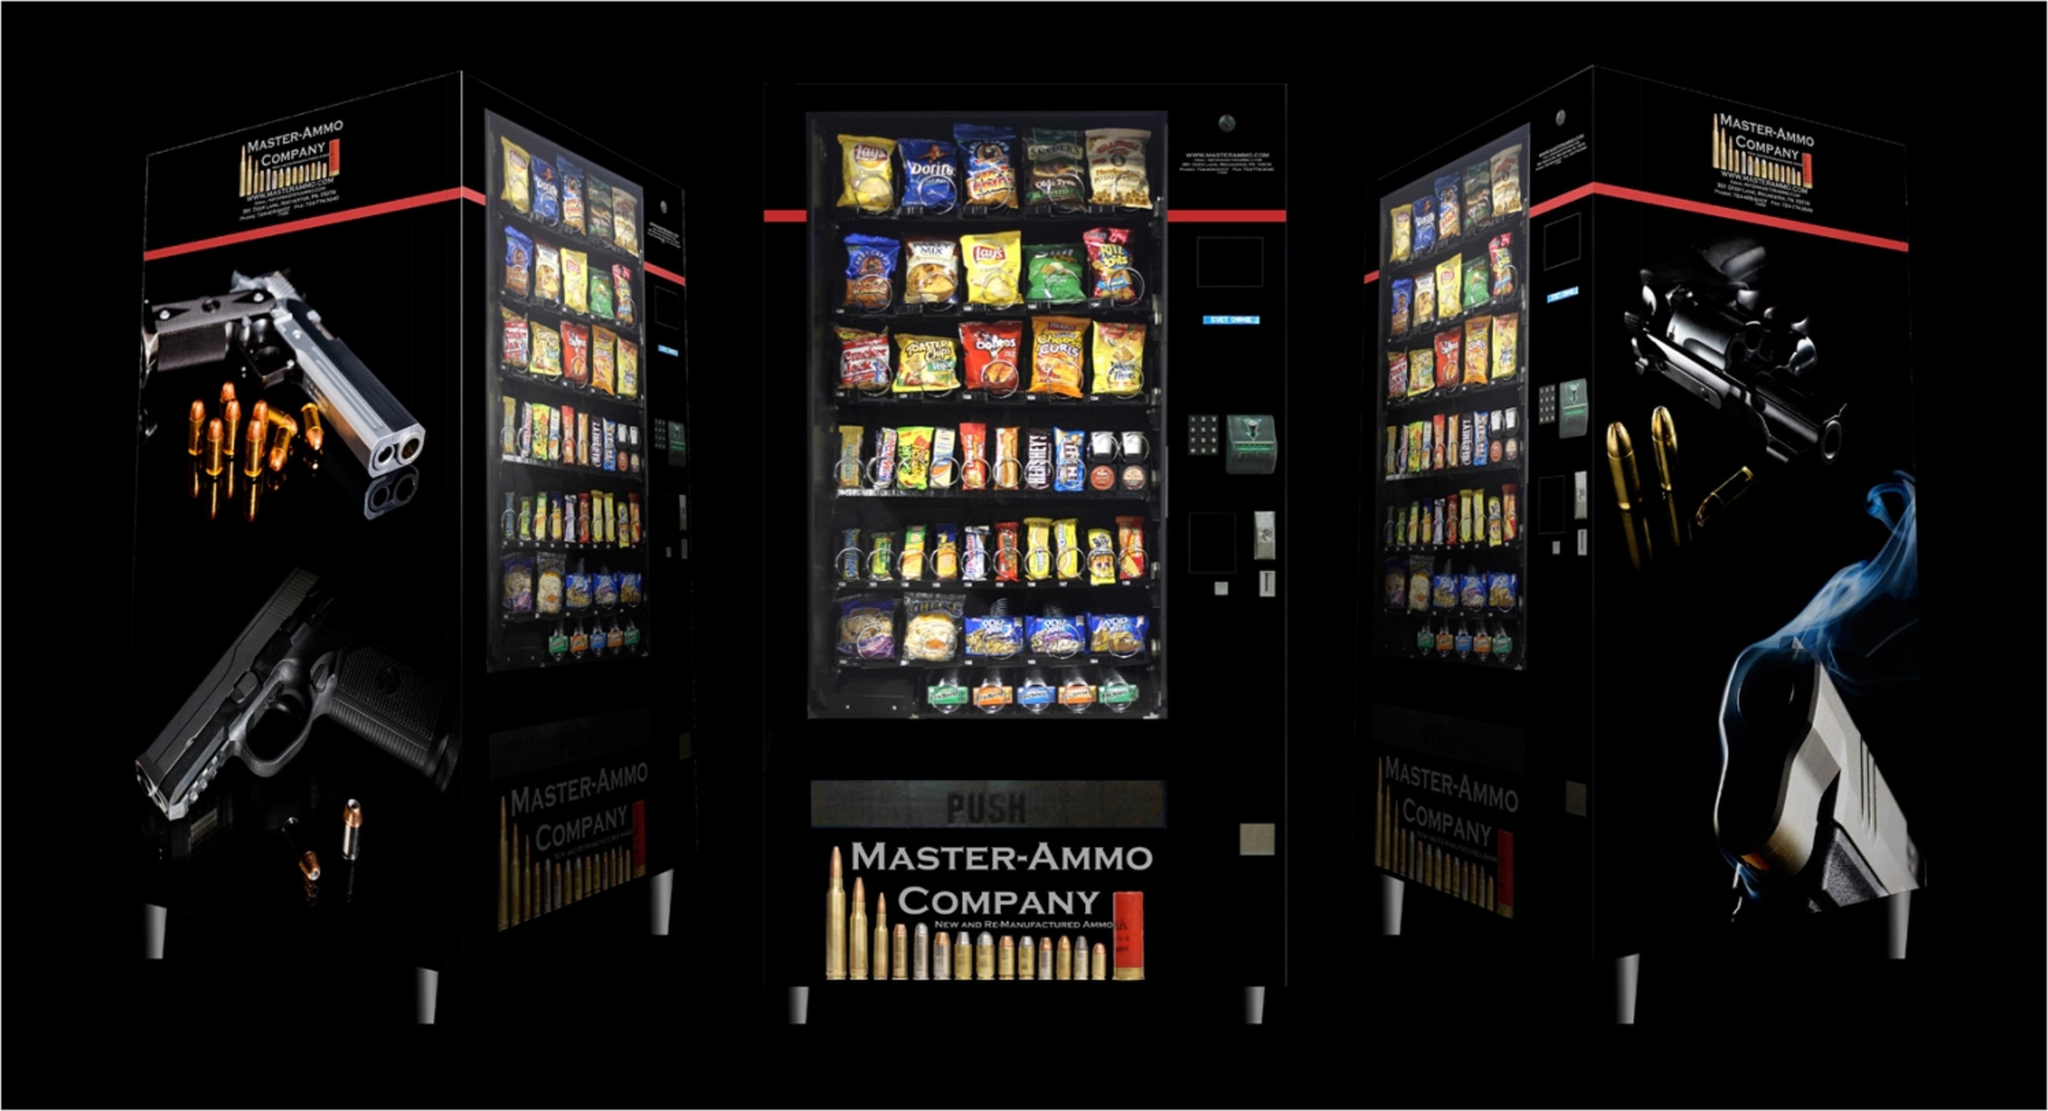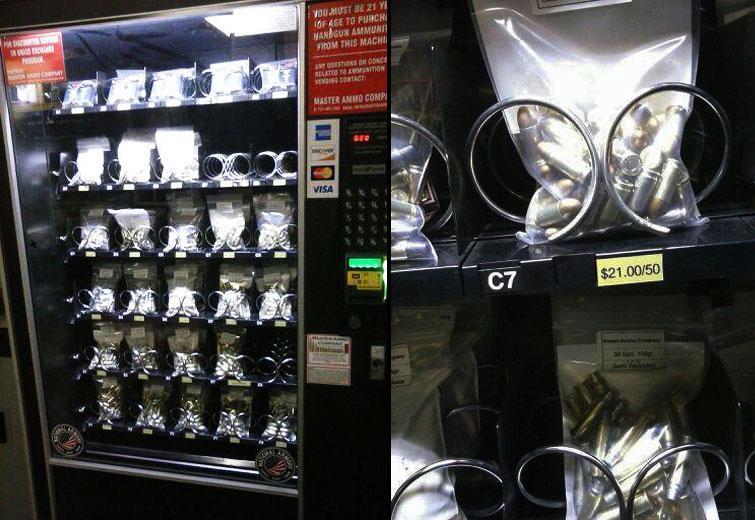The first image is the image on the left, the second image is the image on the right. Assess this claim about the two images: "One of these machines is red.". Correct or not? Answer yes or no. No. 